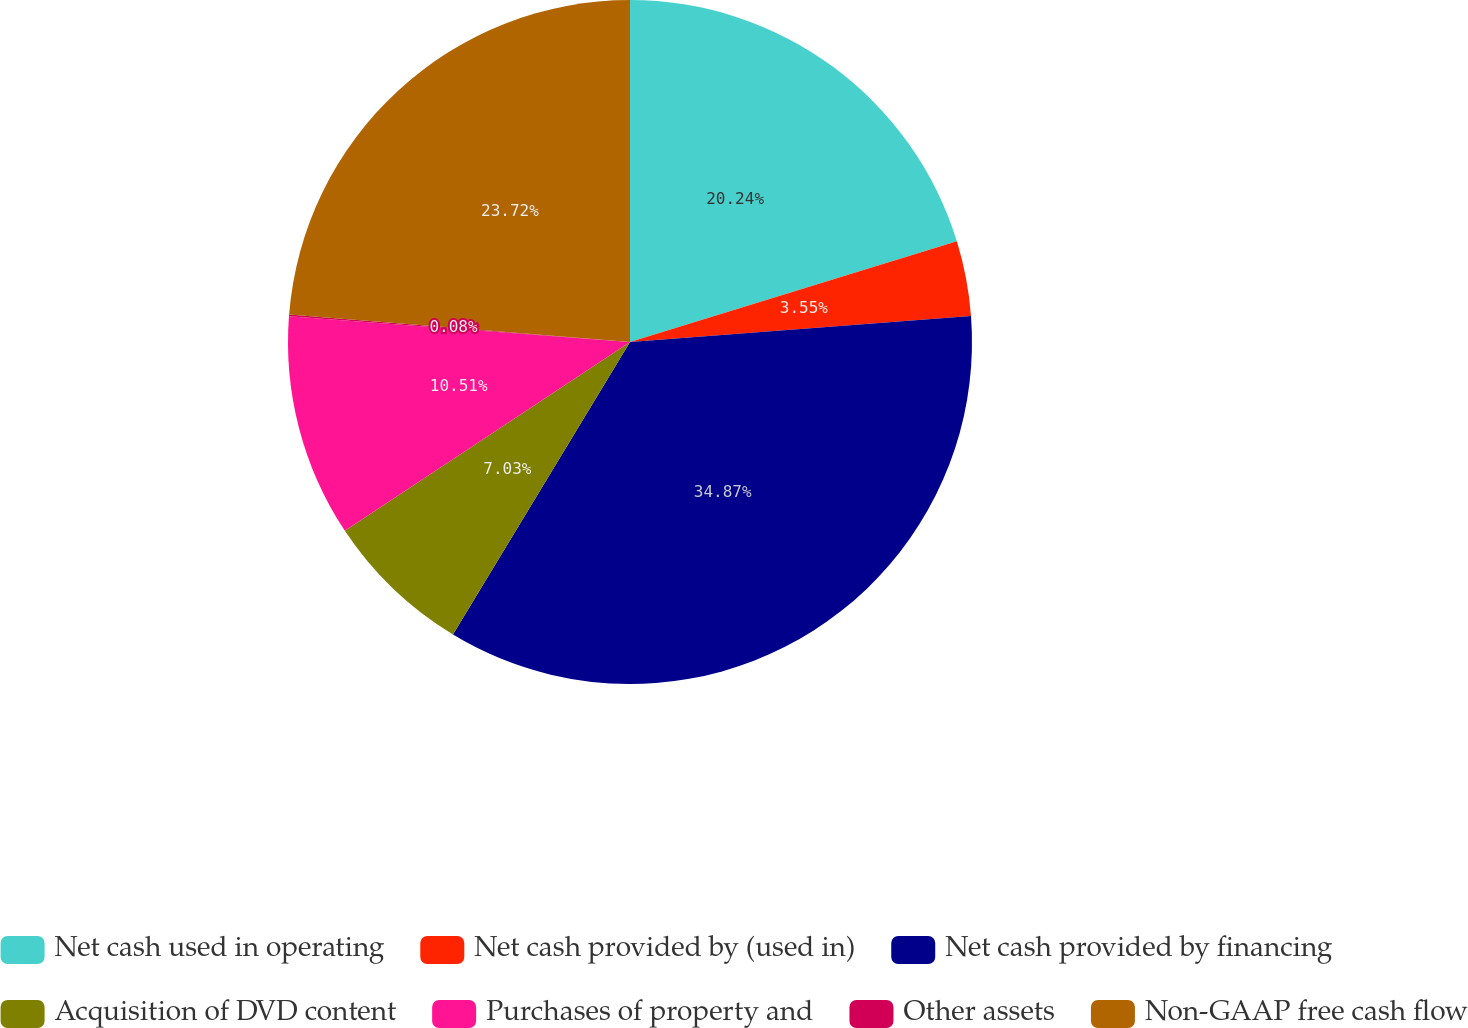<chart> <loc_0><loc_0><loc_500><loc_500><pie_chart><fcel>Net cash used in operating<fcel>Net cash provided by (used in)<fcel>Net cash provided by financing<fcel>Acquisition of DVD content<fcel>Purchases of property and<fcel>Other assets<fcel>Non-GAAP free cash flow<nl><fcel>20.24%<fcel>3.55%<fcel>34.87%<fcel>7.03%<fcel>10.51%<fcel>0.08%<fcel>23.72%<nl></chart> 